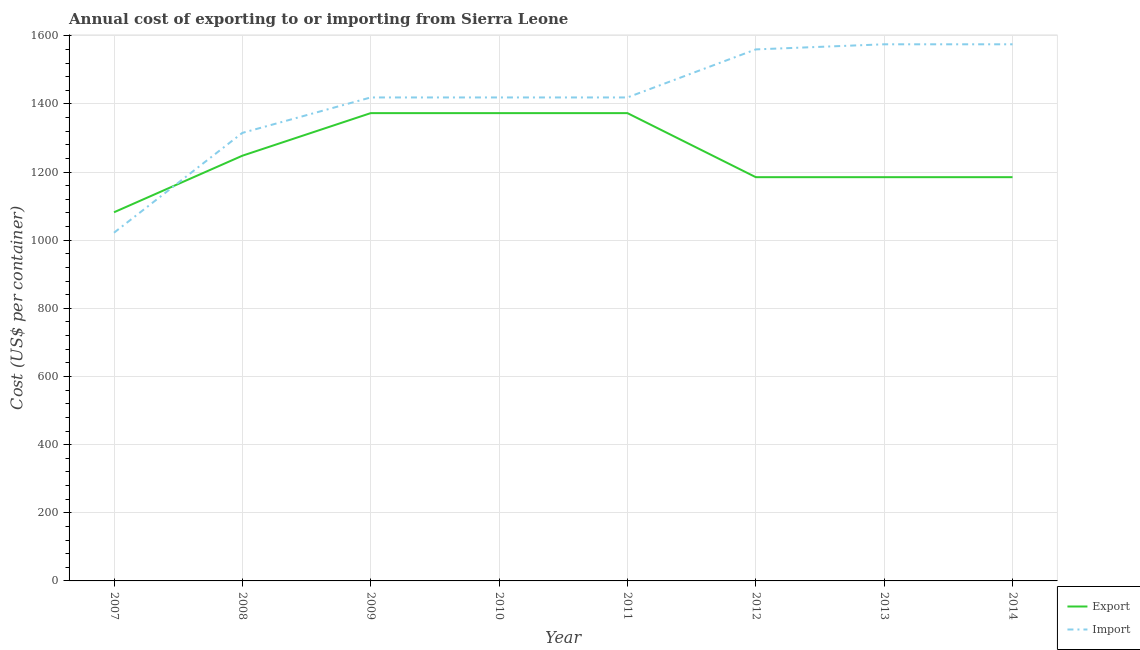What is the export cost in 2007?
Your answer should be compact. 1082. Across all years, what is the maximum export cost?
Give a very brief answer. 1373. Across all years, what is the minimum import cost?
Make the answer very short. 1022. In which year was the export cost maximum?
Offer a terse response. 2009. In which year was the import cost minimum?
Give a very brief answer. 2007. What is the total import cost in the graph?
Offer a very short reply. 1.13e+04. What is the difference between the import cost in 2010 and that in 2011?
Provide a succinct answer. 0. What is the difference between the import cost in 2012 and the export cost in 2009?
Provide a succinct answer. 187. What is the average export cost per year?
Keep it short and to the point. 1250.5. In the year 2010, what is the difference between the export cost and import cost?
Offer a very short reply. -46. What is the ratio of the export cost in 2008 to that in 2010?
Provide a succinct answer. 0.91. Is the import cost in 2007 less than that in 2010?
Your answer should be very brief. Yes. What is the difference between the highest and the second highest import cost?
Offer a terse response. 0. What is the difference between the highest and the lowest export cost?
Provide a succinct answer. 291. In how many years, is the import cost greater than the average import cost taken over all years?
Your answer should be compact. 6. Is the import cost strictly greater than the export cost over the years?
Keep it short and to the point. No. Is the export cost strictly less than the import cost over the years?
Offer a very short reply. No. How many years are there in the graph?
Offer a terse response. 8. What is the difference between two consecutive major ticks on the Y-axis?
Make the answer very short. 200. Does the graph contain grids?
Ensure brevity in your answer.  Yes. Where does the legend appear in the graph?
Ensure brevity in your answer.  Bottom right. How many legend labels are there?
Your response must be concise. 2. What is the title of the graph?
Give a very brief answer. Annual cost of exporting to or importing from Sierra Leone. Does "Nonresident" appear as one of the legend labels in the graph?
Your answer should be compact. No. What is the label or title of the Y-axis?
Provide a succinct answer. Cost (US$ per container). What is the Cost (US$ per container) of Export in 2007?
Offer a terse response. 1082. What is the Cost (US$ per container) of Import in 2007?
Keep it short and to the point. 1022. What is the Cost (US$ per container) in Export in 2008?
Give a very brief answer. 1248. What is the Cost (US$ per container) of Import in 2008?
Your answer should be very brief. 1315. What is the Cost (US$ per container) of Export in 2009?
Provide a short and direct response. 1373. What is the Cost (US$ per container) of Import in 2009?
Your answer should be very brief. 1419. What is the Cost (US$ per container) of Export in 2010?
Offer a terse response. 1373. What is the Cost (US$ per container) of Import in 2010?
Your response must be concise. 1419. What is the Cost (US$ per container) of Export in 2011?
Ensure brevity in your answer.  1373. What is the Cost (US$ per container) in Import in 2011?
Give a very brief answer. 1419. What is the Cost (US$ per container) of Export in 2012?
Your answer should be compact. 1185. What is the Cost (US$ per container) of Import in 2012?
Provide a short and direct response. 1560. What is the Cost (US$ per container) in Export in 2013?
Your answer should be compact. 1185. What is the Cost (US$ per container) in Import in 2013?
Your answer should be very brief. 1575. What is the Cost (US$ per container) in Export in 2014?
Provide a short and direct response. 1185. What is the Cost (US$ per container) in Import in 2014?
Your answer should be compact. 1575. Across all years, what is the maximum Cost (US$ per container) in Export?
Make the answer very short. 1373. Across all years, what is the maximum Cost (US$ per container) of Import?
Make the answer very short. 1575. Across all years, what is the minimum Cost (US$ per container) in Export?
Your answer should be compact. 1082. Across all years, what is the minimum Cost (US$ per container) in Import?
Offer a very short reply. 1022. What is the total Cost (US$ per container) in Export in the graph?
Offer a very short reply. 1.00e+04. What is the total Cost (US$ per container) in Import in the graph?
Offer a terse response. 1.13e+04. What is the difference between the Cost (US$ per container) in Export in 2007 and that in 2008?
Offer a terse response. -166. What is the difference between the Cost (US$ per container) of Import in 2007 and that in 2008?
Provide a succinct answer. -293. What is the difference between the Cost (US$ per container) in Export in 2007 and that in 2009?
Keep it short and to the point. -291. What is the difference between the Cost (US$ per container) of Import in 2007 and that in 2009?
Offer a terse response. -397. What is the difference between the Cost (US$ per container) of Export in 2007 and that in 2010?
Give a very brief answer. -291. What is the difference between the Cost (US$ per container) in Import in 2007 and that in 2010?
Provide a succinct answer. -397. What is the difference between the Cost (US$ per container) in Export in 2007 and that in 2011?
Provide a short and direct response. -291. What is the difference between the Cost (US$ per container) of Import in 2007 and that in 2011?
Your answer should be compact. -397. What is the difference between the Cost (US$ per container) in Export in 2007 and that in 2012?
Provide a short and direct response. -103. What is the difference between the Cost (US$ per container) of Import in 2007 and that in 2012?
Give a very brief answer. -538. What is the difference between the Cost (US$ per container) in Export in 2007 and that in 2013?
Offer a terse response. -103. What is the difference between the Cost (US$ per container) of Import in 2007 and that in 2013?
Your answer should be very brief. -553. What is the difference between the Cost (US$ per container) of Export in 2007 and that in 2014?
Your response must be concise. -103. What is the difference between the Cost (US$ per container) of Import in 2007 and that in 2014?
Your answer should be compact. -553. What is the difference between the Cost (US$ per container) of Export in 2008 and that in 2009?
Offer a terse response. -125. What is the difference between the Cost (US$ per container) of Import in 2008 and that in 2009?
Your answer should be compact. -104. What is the difference between the Cost (US$ per container) in Export in 2008 and that in 2010?
Ensure brevity in your answer.  -125. What is the difference between the Cost (US$ per container) of Import in 2008 and that in 2010?
Provide a succinct answer. -104. What is the difference between the Cost (US$ per container) in Export in 2008 and that in 2011?
Offer a very short reply. -125. What is the difference between the Cost (US$ per container) in Import in 2008 and that in 2011?
Keep it short and to the point. -104. What is the difference between the Cost (US$ per container) of Export in 2008 and that in 2012?
Make the answer very short. 63. What is the difference between the Cost (US$ per container) of Import in 2008 and that in 2012?
Your answer should be compact. -245. What is the difference between the Cost (US$ per container) in Export in 2008 and that in 2013?
Provide a short and direct response. 63. What is the difference between the Cost (US$ per container) in Import in 2008 and that in 2013?
Offer a very short reply. -260. What is the difference between the Cost (US$ per container) in Export in 2008 and that in 2014?
Offer a terse response. 63. What is the difference between the Cost (US$ per container) in Import in 2008 and that in 2014?
Provide a succinct answer. -260. What is the difference between the Cost (US$ per container) of Import in 2009 and that in 2010?
Ensure brevity in your answer.  0. What is the difference between the Cost (US$ per container) of Export in 2009 and that in 2011?
Offer a terse response. 0. What is the difference between the Cost (US$ per container) of Export in 2009 and that in 2012?
Keep it short and to the point. 188. What is the difference between the Cost (US$ per container) in Import in 2009 and that in 2012?
Make the answer very short. -141. What is the difference between the Cost (US$ per container) of Export in 2009 and that in 2013?
Offer a very short reply. 188. What is the difference between the Cost (US$ per container) in Import in 2009 and that in 2013?
Give a very brief answer. -156. What is the difference between the Cost (US$ per container) of Export in 2009 and that in 2014?
Your answer should be compact. 188. What is the difference between the Cost (US$ per container) in Import in 2009 and that in 2014?
Offer a very short reply. -156. What is the difference between the Cost (US$ per container) of Export in 2010 and that in 2011?
Offer a terse response. 0. What is the difference between the Cost (US$ per container) of Export in 2010 and that in 2012?
Your answer should be compact. 188. What is the difference between the Cost (US$ per container) in Import in 2010 and that in 2012?
Provide a short and direct response. -141. What is the difference between the Cost (US$ per container) in Export in 2010 and that in 2013?
Your answer should be very brief. 188. What is the difference between the Cost (US$ per container) of Import in 2010 and that in 2013?
Give a very brief answer. -156. What is the difference between the Cost (US$ per container) of Export in 2010 and that in 2014?
Give a very brief answer. 188. What is the difference between the Cost (US$ per container) of Import in 2010 and that in 2014?
Ensure brevity in your answer.  -156. What is the difference between the Cost (US$ per container) in Export in 2011 and that in 2012?
Your answer should be compact. 188. What is the difference between the Cost (US$ per container) of Import in 2011 and that in 2012?
Your answer should be compact. -141. What is the difference between the Cost (US$ per container) in Export in 2011 and that in 2013?
Give a very brief answer. 188. What is the difference between the Cost (US$ per container) of Import in 2011 and that in 2013?
Provide a succinct answer. -156. What is the difference between the Cost (US$ per container) in Export in 2011 and that in 2014?
Your response must be concise. 188. What is the difference between the Cost (US$ per container) in Import in 2011 and that in 2014?
Keep it short and to the point. -156. What is the difference between the Cost (US$ per container) of Export in 2012 and that in 2013?
Your answer should be very brief. 0. What is the difference between the Cost (US$ per container) in Import in 2012 and that in 2013?
Offer a terse response. -15. What is the difference between the Cost (US$ per container) of Export in 2012 and that in 2014?
Your answer should be very brief. 0. What is the difference between the Cost (US$ per container) of Import in 2012 and that in 2014?
Provide a short and direct response. -15. What is the difference between the Cost (US$ per container) in Export in 2007 and the Cost (US$ per container) in Import in 2008?
Offer a terse response. -233. What is the difference between the Cost (US$ per container) in Export in 2007 and the Cost (US$ per container) in Import in 2009?
Provide a short and direct response. -337. What is the difference between the Cost (US$ per container) in Export in 2007 and the Cost (US$ per container) in Import in 2010?
Offer a very short reply. -337. What is the difference between the Cost (US$ per container) of Export in 2007 and the Cost (US$ per container) of Import in 2011?
Provide a short and direct response. -337. What is the difference between the Cost (US$ per container) in Export in 2007 and the Cost (US$ per container) in Import in 2012?
Your answer should be very brief. -478. What is the difference between the Cost (US$ per container) in Export in 2007 and the Cost (US$ per container) in Import in 2013?
Offer a very short reply. -493. What is the difference between the Cost (US$ per container) of Export in 2007 and the Cost (US$ per container) of Import in 2014?
Offer a very short reply. -493. What is the difference between the Cost (US$ per container) of Export in 2008 and the Cost (US$ per container) of Import in 2009?
Offer a very short reply. -171. What is the difference between the Cost (US$ per container) in Export in 2008 and the Cost (US$ per container) in Import in 2010?
Ensure brevity in your answer.  -171. What is the difference between the Cost (US$ per container) of Export in 2008 and the Cost (US$ per container) of Import in 2011?
Your answer should be very brief. -171. What is the difference between the Cost (US$ per container) in Export in 2008 and the Cost (US$ per container) in Import in 2012?
Make the answer very short. -312. What is the difference between the Cost (US$ per container) in Export in 2008 and the Cost (US$ per container) in Import in 2013?
Your answer should be very brief. -327. What is the difference between the Cost (US$ per container) in Export in 2008 and the Cost (US$ per container) in Import in 2014?
Make the answer very short. -327. What is the difference between the Cost (US$ per container) of Export in 2009 and the Cost (US$ per container) of Import in 2010?
Offer a very short reply. -46. What is the difference between the Cost (US$ per container) of Export in 2009 and the Cost (US$ per container) of Import in 2011?
Your answer should be very brief. -46. What is the difference between the Cost (US$ per container) in Export in 2009 and the Cost (US$ per container) in Import in 2012?
Your answer should be very brief. -187. What is the difference between the Cost (US$ per container) in Export in 2009 and the Cost (US$ per container) in Import in 2013?
Ensure brevity in your answer.  -202. What is the difference between the Cost (US$ per container) in Export in 2009 and the Cost (US$ per container) in Import in 2014?
Your answer should be very brief. -202. What is the difference between the Cost (US$ per container) of Export in 2010 and the Cost (US$ per container) of Import in 2011?
Your response must be concise. -46. What is the difference between the Cost (US$ per container) of Export in 2010 and the Cost (US$ per container) of Import in 2012?
Offer a terse response. -187. What is the difference between the Cost (US$ per container) in Export in 2010 and the Cost (US$ per container) in Import in 2013?
Make the answer very short. -202. What is the difference between the Cost (US$ per container) in Export in 2010 and the Cost (US$ per container) in Import in 2014?
Offer a very short reply. -202. What is the difference between the Cost (US$ per container) in Export in 2011 and the Cost (US$ per container) in Import in 2012?
Offer a very short reply. -187. What is the difference between the Cost (US$ per container) of Export in 2011 and the Cost (US$ per container) of Import in 2013?
Provide a short and direct response. -202. What is the difference between the Cost (US$ per container) in Export in 2011 and the Cost (US$ per container) in Import in 2014?
Your response must be concise. -202. What is the difference between the Cost (US$ per container) of Export in 2012 and the Cost (US$ per container) of Import in 2013?
Provide a succinct answer. -390. What is the difference between the Cost (US$ per container) of Export in 2012 and the Cost (US$ per container) of Import in 2014?
Provide a short and direct response. -390. What is the difference between the Cost (US$ per container) of Export in 2013 and the Cost (US$ per container) of Import in 2014?
Your answer should be very brief. -390. What is the average Cost (US$ per container) of Export per year?
Provide a short and direct response. 1250.5. What is the average Cost (US$ per container) in Import per year?
Provide a succinct answer. 1413. In the year 2007, what is the difference between the Cost (US$ per container) of Export and Cost (US$ per container) of Import?
Your response must be concise. 60. In the year 2008, what is the difference between the Cost (US$ per container) in Export and Cost (US$ per container) in Import?
Offer a terse response. -67. In the year 2009, what is the difference between the Cost (US$ per container) of Export and Cost (US$ per container) of Import?
Offer a very short reply. -46. In the year 2010, what is the difference between the Cost (US$ per container) of Export and Cost (US$ per container) of Import?
Your answer should be compact. -46. In the year 2011, what is the difference between the Cost (US$ per container) of Export and Cost (US$ per container) of Import?
Your answer should be compact. -46. In the year 2012, what is the difference between the Cost (US$ per container) of Export and Cost (US$ per container) of Import?
Your response must be concise. -375. In the year 2013, what is the difference between the Cost (US$ per container) of Export and Cost (US$ per container) of Import?
Offer a very short reply. -390. In the year 2014, what is the difference between the Cost (US$ per container) in Export and Cost (US$ per container) in Import?
Give a very brief answer. -390. What is the ratio of the Cost (US$ per container) of Export in 2007 to that in 2008?
Your answer should be very brief. 0.87. What is the ratio of the Cost (US$ per container) in Import in 2007 to that in 2008?
Your response must be concise. 0.78. What is the ratio of the Cost (US$ per container) of Export in 2007 to that in 2009?
Keep it short and to the point. 0.79. What is the ratio of the Cost (US$ per container) of Import in 2007 to that in 2009?
Provide a succinct answer. 0.72. What is the ratio of the Cost (US$ per container) of Export in 2007 to that in 2010?
Offer a terse response. 0.79. What is the ratio of the Cost (US$ per container) in Import in 2007 to that in 2010?
Give a very brief answer. 0.72. What is the ratio of the Cost (US$ per container) in Export in 2007 to that in 2011?
Provide a short and direct response. 0.79. What is the ratio of the Cost (US$ per container) in Import in 2007 to that in 2011?
Provide a succinct answer. 0.72. What is the ratio of the Cost (US$ per container) in Export in 2007 to that in 2012?
Your response must be concise. 0.91. What is the ratio of the Cost (US$ per container) of Import in 2007 to that in 2012?
Offer a terse response. 0.66. What is the ratio of the Cost (US$ per container) of Export in 2007 to that in 2013?
Your response must be concise. 0.91. What is the ratio of the Cost (US$ per container) in Import in 2007 to that in 2013?
Your answer should be compact. 0.65. What is the ratio of the Cost (US$ per container) of Export in 2007 to that in 2014?
Your answer should be very brief. 0.91. What is the ratio of the Cost (US$ per container) of Import in 2007 to that in 2014?
Offer a terse response. 0.65. What is the ratio of the Cost (US$ per container) of Export in 2008 to that in 2009?
Keep it short and to the point. 0.91. What is the ratio of the Cost (US$ per container) of Import in 2008 to that in 2009?
Ensure brevity in your answer.  0.93. What is the ratio of the Cost (US$ per container) in Export in 2008 to that in 2010?
Keep it short and to the point. 0.91. What is the ratio of the Cost (US$ per container) in Import in 2008 to that in 2010?
Provide a succinct answer. 0.93. What is the ratio of the Cost (US$ per container) in Export in 2008 to that in 2011?
Your response must be concise. 0.91. What is the ratio of the Cost (US$ per container) in Import in 2008 to that in 2011?
Give a very brief answer. 0.93. What is the ratio of the Cost (US$ per container) of Export in 2008 to that in 2012?
Keep it short and to the point. 1.05. What is the ratio of the Cost (US$ per container) of Import in 2008 to that in 2012?
Offer a very short reply. 0.84. What is the ratio of the Cost (US$ per container) in Export in 2008 to that in 2013?
Your response must be concise. 1.05. What is the ratio of the Cost (US$ per container) in Import in 2008 to that in 2013?
Your answer should be very brief. 0.83. What is the ratio of the Cost (US$ per container) in Export in 2008 to that in 2014?
Provide a short and direct response. 1.05. What is the ratio of the Cost (US$ per container) in Import in 2008 to that in 2014?
Give a very brief answer. 0.83. What is the ratio of the Cost (US$ per container) in Export in 2009 to that in 2010?
Your response must be concise. 1. What is the ratio of the Cost (US$ per container) of Export in 2009 to that in 2011?
Ensure brevity in your answer.  1. What is the ratio of the Cost (US$ per container) of Export in 2009 to that in 2012?
Ensure brevity in your answer.  1.16. What is the ratio of the Cost (US$ per container) of Import in 2009 to that in 2012?
Make the answer very short. 0.91. What is the ratio of the Cost (US$ per container) of Export in 2009 to that in 2013?
Give a very brief answer. 1.16. What is the ratio of the Cost (US$ per container) of Import in 2009 to that in 2013?
Offer a very short reply. 0.9. What is the ratio of the Cost (US$ per container) in Export in 2009 to that in 2014?
Keep it short and to the point. 1.16. What is the ratio of the Cost (US$ per container) of Import in 2009 to that in 2014?
Offer a terse response. 0.9. What is the ratio of the Cost (US$ per container) of Export in 2010 to that in 2011?
Your answer should be very brief. 1. What is the ratio of the Cost (US$ per container) of Import in 2010 to that in 2011?
Offer a very short reply. 1. What is the ratio of the Cost (US$ per container) in Export in 2010 to that in 2012?
Make the answer very short. 1.16. What is the ratio of the Cost (US$ per container) of Import in 2010 to that in 2012?
Offer a very short reply. 0.91. What is the ratio of the Cost (US$ per container) in Export in 2010 to that in 2013?
Ensure brevity in your answer.  1.16. What is the ratio of the Cost (US$ per container) in Import in 2010 to that in 2013?
Offer a very short reply. 0.9. What is the ratio of the Cost (US$ per container) of Export in 2010 to that in 2014?
Ensure brevity in your answer.  1.16. What is the ratio of the Cost (US$ per container) of Import in 2010 to that in 2014?
Provide a short and direct response. 0.9. What is the ratio of the Cost (US$ per container) in Export in 2011 to that in 2012?
Make the answer very short. 1.16. What is the ratio of the Cost (US$ per container) of Import in 2011 to that in 2012?
Your answer should be very brief. 0.91. What is the ratio of the Cost (US$ per container) in Export in 2011 to that in 2013?
Your response must be concise. 1.16. What is the ratio of the Cost (US$ per container) of Import in 2011 to that in 2013?
Offer a very short reply. 0.9. What is the ratio of the Cost (US$ per container) in Export in 2011 to that in 2014?
Your answer should be compact. 1.16. What is the ratio of the Cost (US$ per container) of Import in 2011 to that in 2014?
Your answer should be very brief. 0.9. What is the ratio of the Cost (US$ per container) in Export in 2012 to that in 2014?
Your answer should be very brief. 1. What is the ratio of the Cost (US$ per container) of Import in 2012 to that in 2014?
Keep it short and to the point. 0.99. What is the ratio of the Cost (US$ per container) of Import in 2013 to that in 2014?
Keep it short and to the point. 1. What is the difference between the highest and the second highest Cost (US$ per container) of Export?
Make the answer very short. 0. What is the difference between the highest and the lowest Cost (US$ per container) in Export?
Make the answer very short. 291. What is the difference between the highest and the lowest Cost (US$ per container) in Import?
Your response must be concise. 553. 